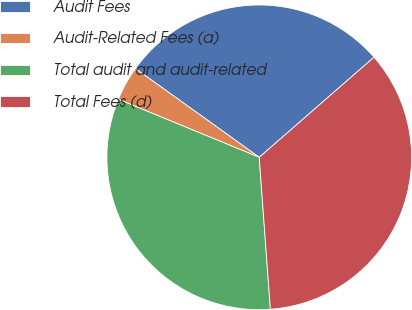Convert chart. <chart><loc_0><loc_0><loc_500><loc_500><pie_chart><fcel>Audit Fees<fcel>Audit-Related Fees (a)<fcel>Total audit and audit-related<fcel>Total Fees (d)<nl><fcel>28.68%<fcel>3.69%<fcel>32.38%<fcel>35.25%<nl></chart> 